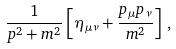Convert formula to latex. <formula><loc_0><loc_0><loc_500><loc_500>\frac { 1 } { p ^ { 2 } + m ^ { 2 } } \left [ \eta _ { \mu \nu } + \frac { p _ { \mu } p _ { \nu } } { m ^ { 2 } } \right ] \, ,</formula> 